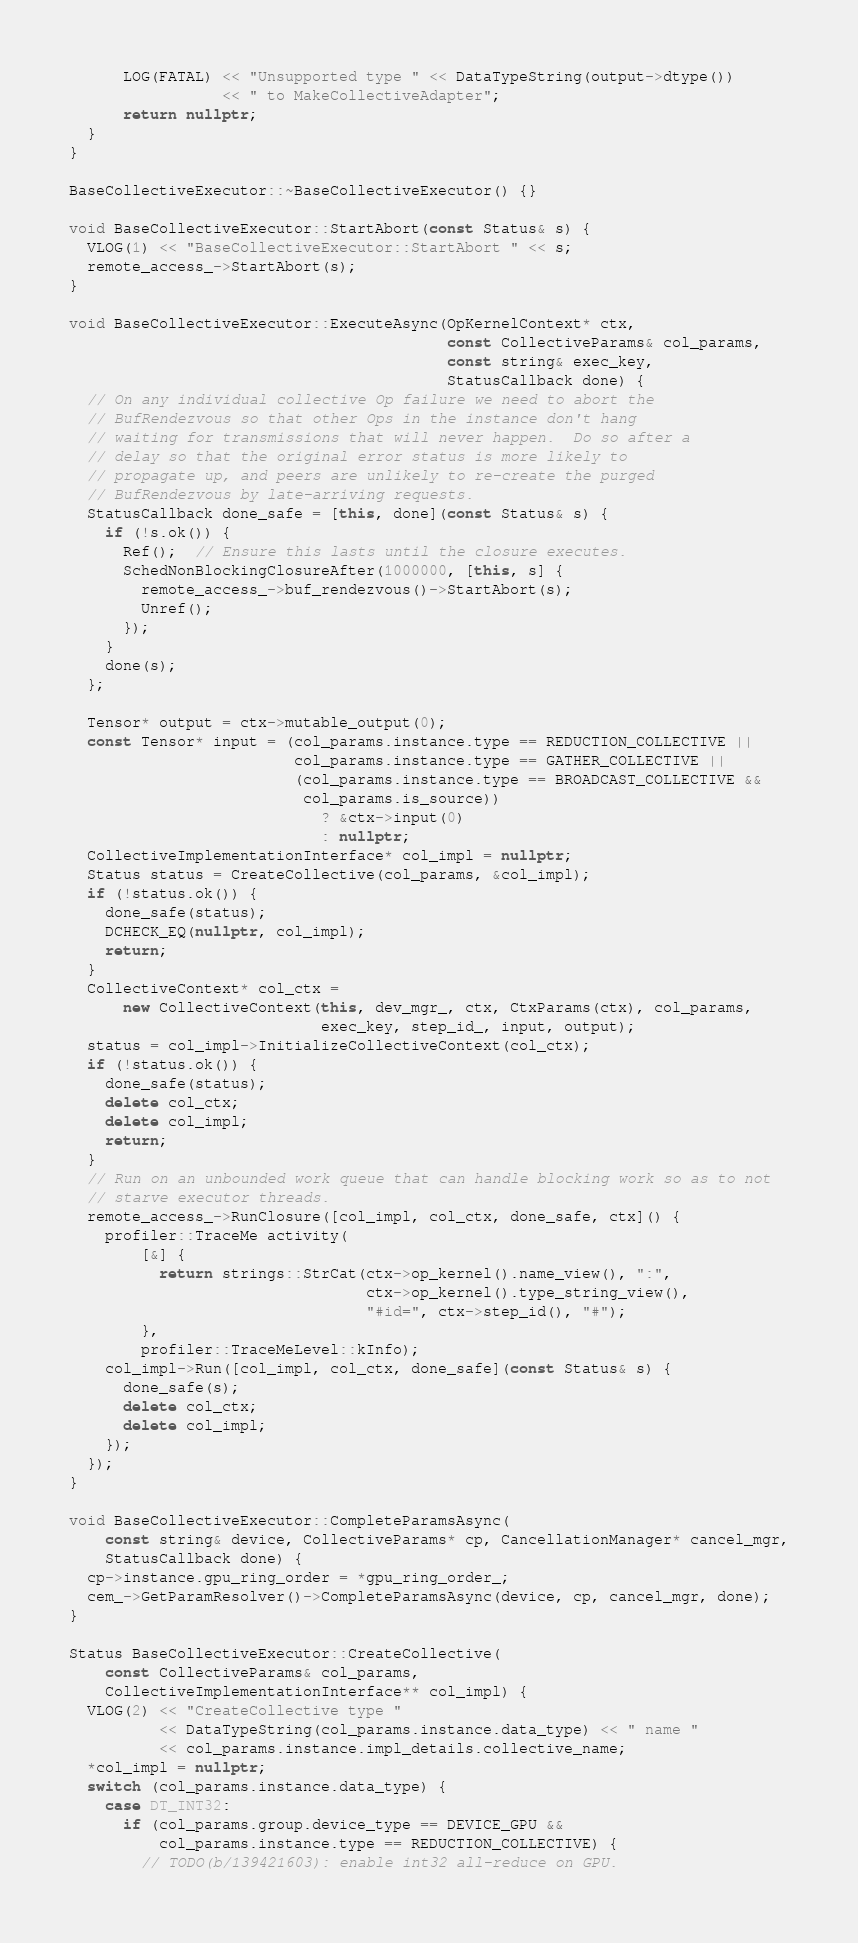<code> <loc_0><loc_0><loc_500><loc_500><_C++_>      LOG(FATAL) << "Unsupported type " << DataTypeString(output->dtype())
                 << " to MakeCollectiveAdapter";
      return nullptr;
  }
}

BaseCollectiveExecutor::~BaseCollectiveExecutor() {}

void BaseCollectiveExecutor::StartAbort(const Status& s) {
  VLOG(1) << "BaseCollectiveExecutor::StartAbort " << s;
  remote_access_->StartAbort(s);
}

void BaseCollectiveExecutor::ExecuteAsync(OpKernelContext* ctx,
                                          const CollectiveParams& col_params,
                                          const string& exec_key,
                                          StatusCallback done) {
  // On any individual collective Op failure we need to abort the
  // BufRendezvous so that other Ops in the instance don't hang
  // waiting for transmissions that will never happen.  Do so after a
  // delay so that the original error status is more likely to
  // propagate up, and peers are unlikely to re-create the purged
  // BufRendezvous by late-arriving requests.
  StatusCallback done_safe = [this, done](const Status& s) {
    if (!s.ok()) {
      Ref();  // Ensure this lasts until the closure executes.
      SchedNonBlockingClosureAfter(1000000, [this, s] {
        remote_access_->buf_rendezvous()->StartAbort(s);
        Unref();
      });
    }
    done(s);
  };

  Tensor* output = ctx->mutable_output(0);
  const Tensor* input = (col_params.instance.type == REDUCTION_COLLECTIVE ||
                         col_params.instance.type == GATHER_COLLECTIVE ||
                         (col_params.instance.type == BROADCAST_COLLECTIVE &&
                          col_params.is_source))
                            ? &ctx->input(0)
                            : nullptr;
  CollectiveImplementationInterface* col_impl = nullptr;
  Status status = CreateCollective(col_params, &col_impl);
  if (!status.ok()) {
    done_safe(status);
    DCHECK_EQ(nullptr, col_impl);
    return;
  }
  CollectiveContext* col_ctx =
      new CollectiveContext(this, dev_mgr_, ctx, CtxParams(ctx), col_params,
                            exec_key, step_id_, input, output);
  status = col_impl->InitializeCollectiveContext(col_ctx);
  if (!status.ok()) {
    done_safe(status);
    delete col_ctx;
    delete col_impl;
    return;
  }
  // Run on an unbounded work queue that can handle blocking work so as to not
  // starve executor threads.
  remote_access_->RunClosure([col_impl, col_ctx, done_safe, ctx]() {
    profiler::TraceMe activity(
        [&] {
          return strings::StrCat(ctx->op_kernel().name_view(), ":",
                                 ctx->op_kernel().type_string_view(),
                                 "#id=", ctx->step_id(), "#");
        },
        profiler::TraceMeLevel::kInfo);
    col_impl->Run([col_impl, col_ctx, done_safe](const Status& s) {
      done_safe(s);
      delete col_ctx;
      delete col_impl;
    });
  });
}

void BaseCollectiveExecutor::CompleteParamsAsync(
    const string& device, CollectiveParams* cp, CancellationManager* cancel_mgr,
    StatusCallback done) {
  cp->instance.gpu_ring_order = *gpu_ring_order_;
  cem_->GetParamResolver()->CompleteParamsAsync(device, cp, cancel_mgr, done);
}

Status BaseCollectiveExecutor::CreateCollective(
    const CollectiveParams& col_params,
    CollectiveImplementationInterface** col_impl) {
  VLOG(2) << "CreateCollective type "
          << DataTypeString(col_params.instance.data_type) << " name "
          << col_params.instance.impl_details.collective_name;
  *col_impl = nullptr;
  switch (col_params.instance.data_type) {
    case DT_INT32:
      if (col_params.group.device_type == DEVICE_GPU &&
          col_params.instance.type == REDUCTION_COLLECTIVE) {
        // TODO(b/139421603): enable int32 all-reduce on GPU.</code> 